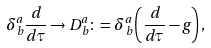<formula> <loc_0><loc_0><loc_500><loc_500>\delta ^ { a } _ { \, b } \frac { d } { d \tau } \rightarrow D ^ { a } _ { \, b } \colon = \delta ^ { a } _ { \, b } \left ( \frac { d } { d \tau } - g \right ) ,</formula> 